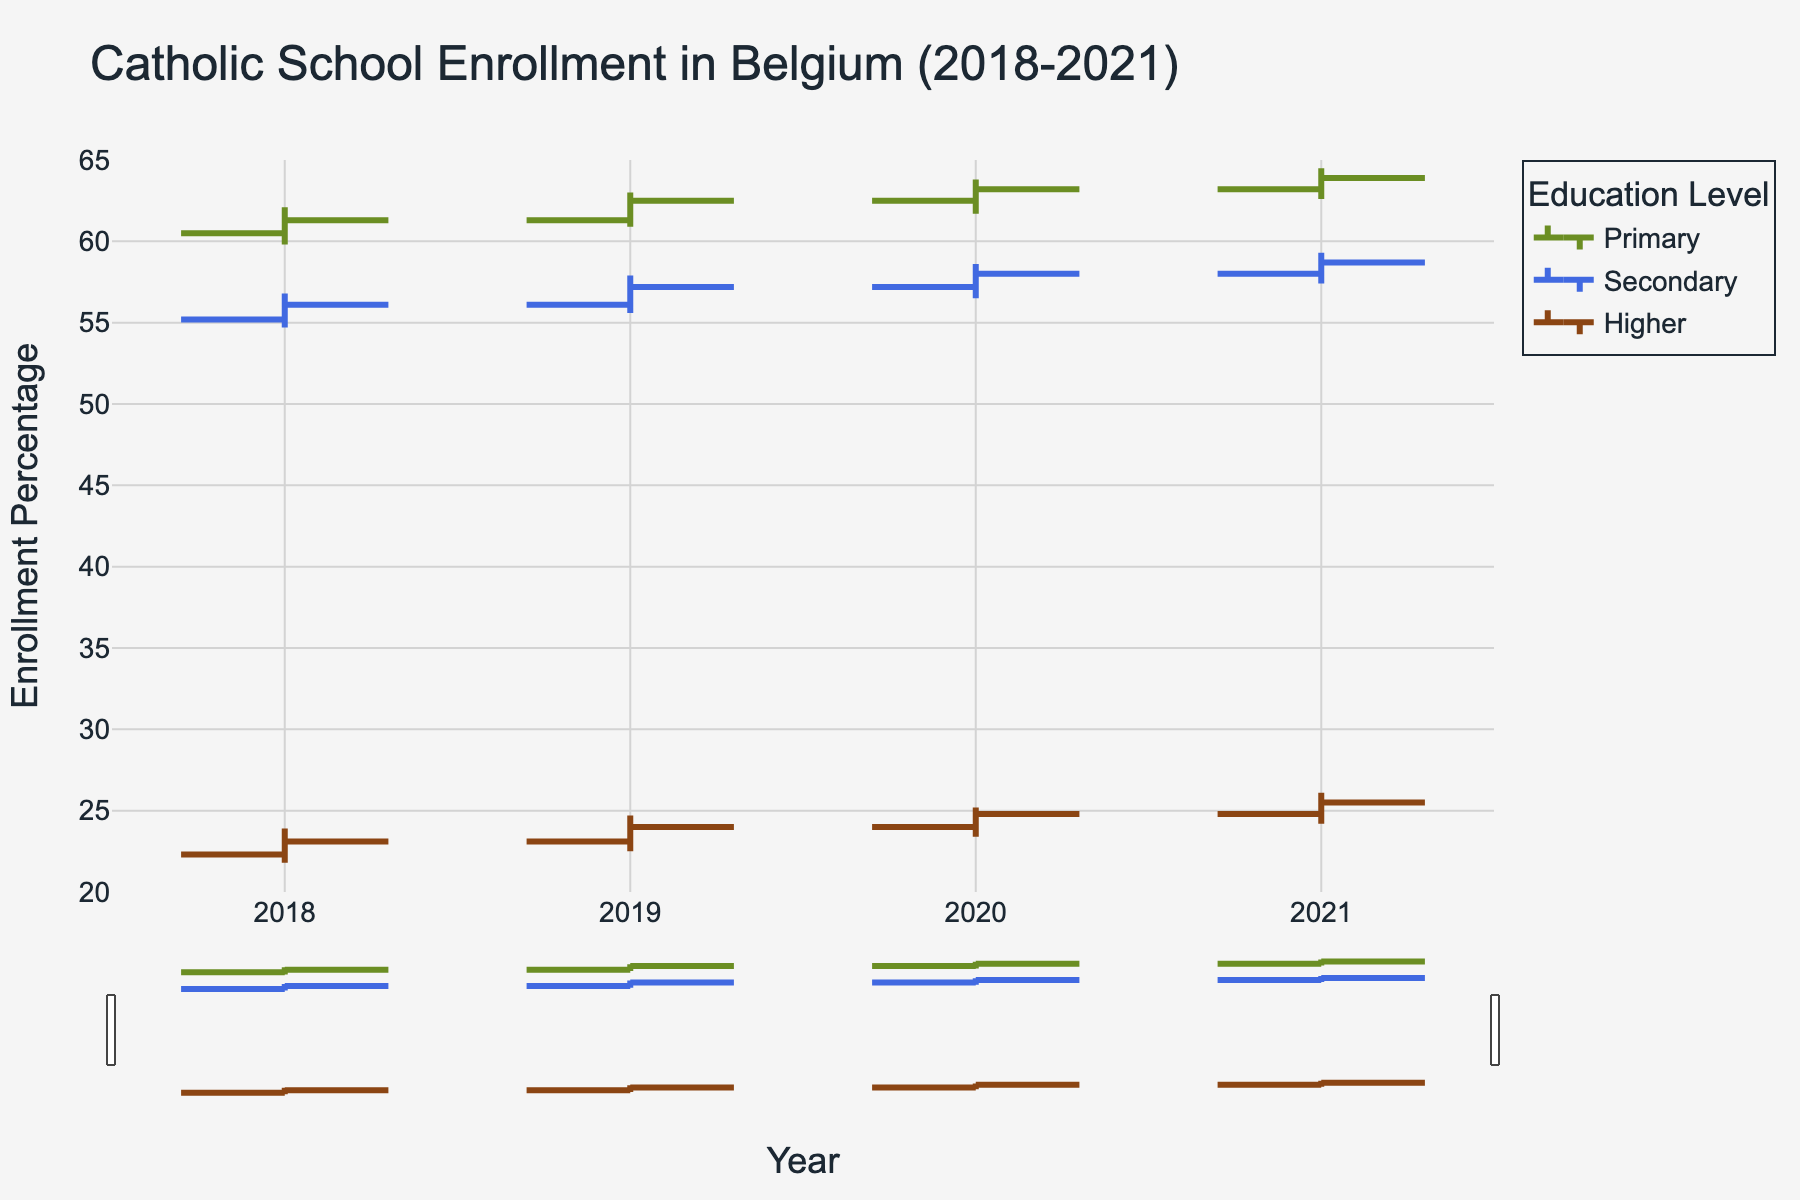What's the title of the figure? The title is displayed at the top center of the figure and reads "Catholic School Enrollment in Belgium (2018-2021)."
Answer: Catholic School Enrollment in Belgium (2018-2021) Which educational level has the highest closing enrollment percentage in 2021? To find the highest closing value in 2021, look at the 'Close' values for each education level in 2021. Primary education has a closing value of 63.9%, which is the highest among all levels.
Answer: Primary What is the primary education enrollment trend from 2018 to 2021? For primary education, compare the closing values over the years: 2018 (61.3), 2019 (62.5), 2020 (63.2), 2021 (63.9). The values show a consistent increase each year.
Answer: Increasing Compare the closing values for secondary education between 2018 and 2021. How much has it changed? Look at the closing values for secondary education: 2018 (56.1) and 2021 (58.7). The change is calculated as 58.7 - 56.1, which equals 2.6.
Answer: 2.6 What year had the lowest closing enrollment percentage for higher education? To find this, compare the closing values of higher education across 2018 (23.1), 2019 (24.0), 2020 (24.8), and 2021 (25.5). The lowest closing value was in 2018.
Answer: 2018 What was the range of enrollment percentages for secondary education in 2020? The range is found by subtracting the lowest value from the highest value for secondary education in 2020: 58.6 (high) - 56.5 (low) = 2.1.
Answer: 2.1 In which year did primary education see the highest fluctuation in enrollment percentage? Fluctuation is determined by the difference between the high and low values. For primary education: 
2018: 62.1 - 59.8 = 2.3
2019: 63.0 - 60.9 = 2.1
2020: 63.8 - 61.7 = 2.1
2021: 64.5 - 62.6 = 1.9
The highest fluctuation was in 2018.
Answer: 2018 How did the enrollment percentage of higher education change from its opening to closing value in 2020? For higher education in 2020, the opening value is 24.0, and the closing value is 24.8. The change is calculated as 24.8 - 24.0 = 0.8.
Answer: Increased by 0.8 Which educational level had the smallest increase in closing values from 2019 to 2020? Compare the closing values increase for each level:
Primary: 63.2 - 62.5 = 0.7
Secondary: 58.0 - 57.2 = 0.8
Higher: 24.8 - 24.0 = 0.8
The smallest increase is in primary education (0.7).
Answer: Primary How does the increasing line color for primary education compare to secondary education? The increasing line color for primary education is greenish (#6B8E23), and the increasing line color for secondary education is bluish (#4169E1).
Answer: Greenish vs. Bluish 